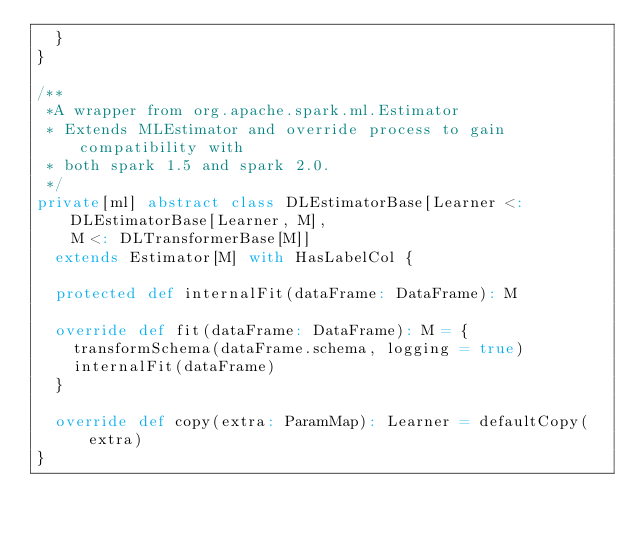Convert code to text. <code><loc_0><loc_0><loc_500><loc_500><_Scala_>  }
}

/**
 *A wrapper from org.apache.spark.ml.Estimator
 * Extends MLEstimator and override process to gain compatibility with
 * both spark 1.5 and spark 2.0.
 */
private[ml] abstract class DLEstimatorBase[Learner <: DLEstimatorBase[Learner, M],
    M <: DLTransformerBase[M]]
  extends Estimator[M] with HasLabelCol {

  protected def internalFit(dataFrame: DataFrame): M

  override def fit(dataFrame: DataFrame): M = {
    transformSchema(dataFrame.schema, logging = true)
    internalFit(dataFrame)
  }

  override def copy(extra: ParamMap): Learner = defaultCopy(extra)
}



</code> 